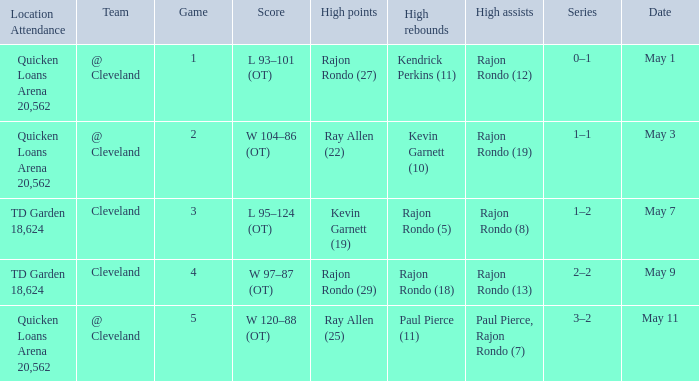Where does the team play May 3? @ Cleveland. 